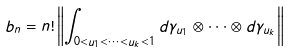Convert formula to latex. <formula><loc_0><loc_0><loc_500><loc_500>b _ { n } = n ! \left \| \int _ { 0 < u _ { 1 } < \dots < u _ { k } < 1 } d \gamma _ { u _ { 1 } } \otimes \dots \otimes d \gamma _ { u _ { k } } \right \|</formula> 